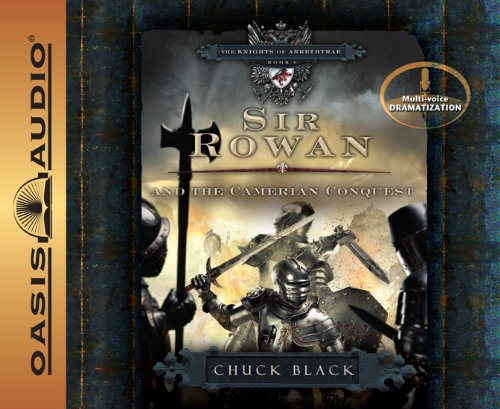Can you describe the armored figure on the cover? The figure on the cover is dressed in intricately detailed armor, suggesting he is a knight of high rank. His stance, holding a sword with a backdrop of a stormy sky, emphasizes themes of battle and valor typical of knightly tales. 